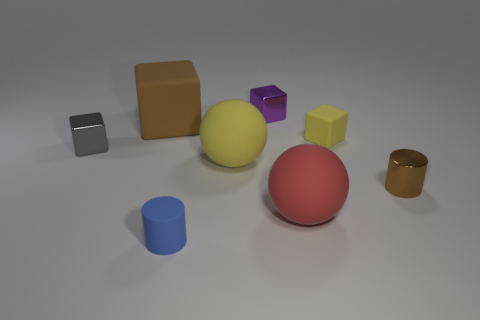Subtract all brown rubber cubes. How many cubes are left? 3 Subtract 1 blocks. How many blocks are left? 3 Add 2 tiny blue matte cubes. How many objects exist? 10 Subtract all brown blocks. How many blocks are left? 3 Subtract all green cubes. Subtract all gray cylinders. How many cubes are left? 4 Subtract 0 cyan cylinders. How many objects are left? 8 Subtract all cylinders. How many objects are left? 6 Subtract all blue matte cylinders. Subtract all brown blocks. How many objects are left? 6 Add 4 small yellow matte cubes. How many small yellow matte cubes are left? 5 Add 7 small yellow rubber cubes. How many small yellow rubber cubes exist? 8 